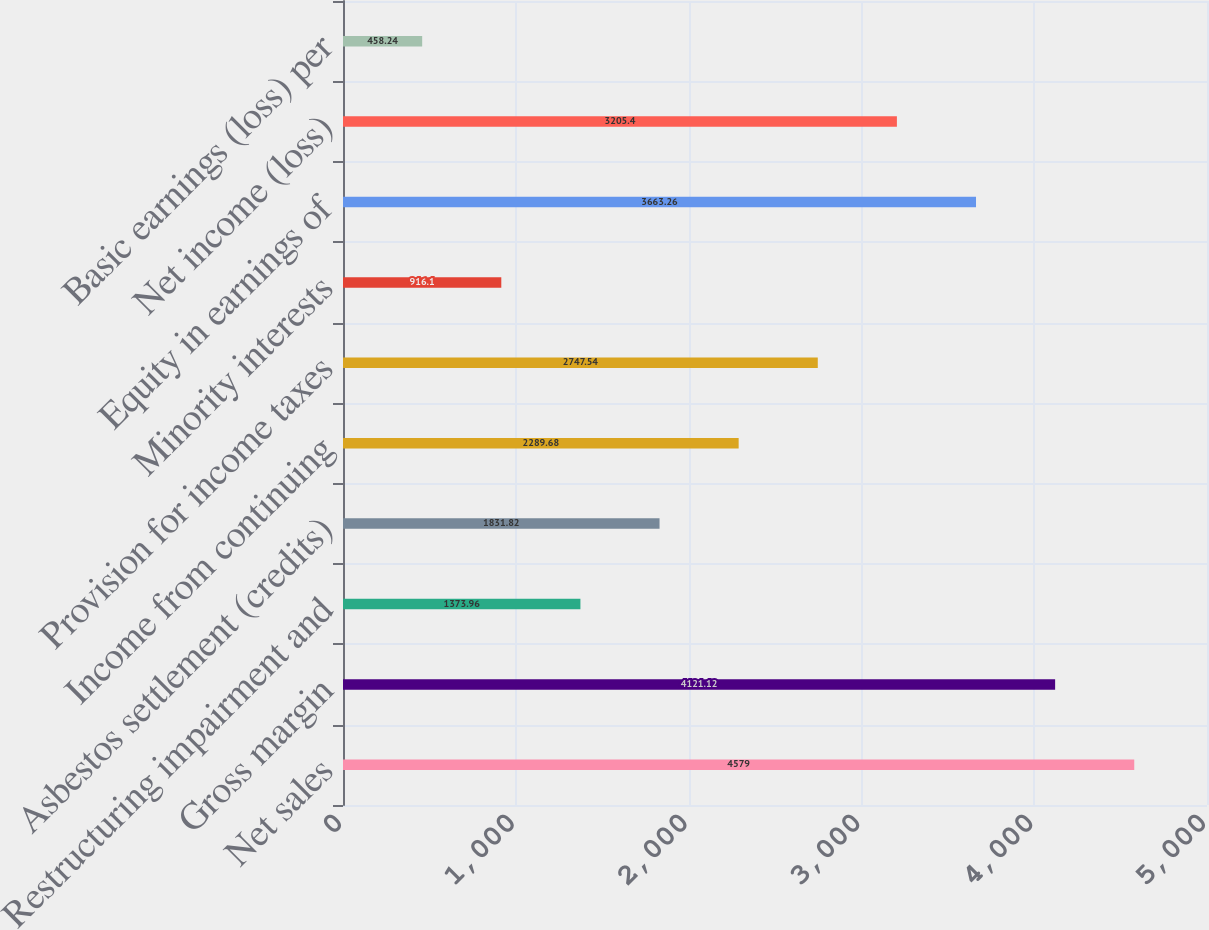Convert chart to OTSL. <chart><loc_0><loc_0><loc_500><loc_500><bar_chart><fcel>Net sales<fcel>Gross margin<fcel>Restructuring impairment and<fcel>Asbestos settlement (credits)<fcel>Income from continuing<fcel>Provision for income taxes<fcel>Minority interests<fcel>Equity in earnings of<fcel>Net income (loss)<fcel>Basic earnings (loss) per<nl><fcel>4579<fcel>4121.12<fcel>1373.96<fcel>1831.82<fcel>2289.68<fcel>2747.54<fcel>916.1<fcel>3663.26<fcel>3205.4<fcel>458.24<nl></chart> 